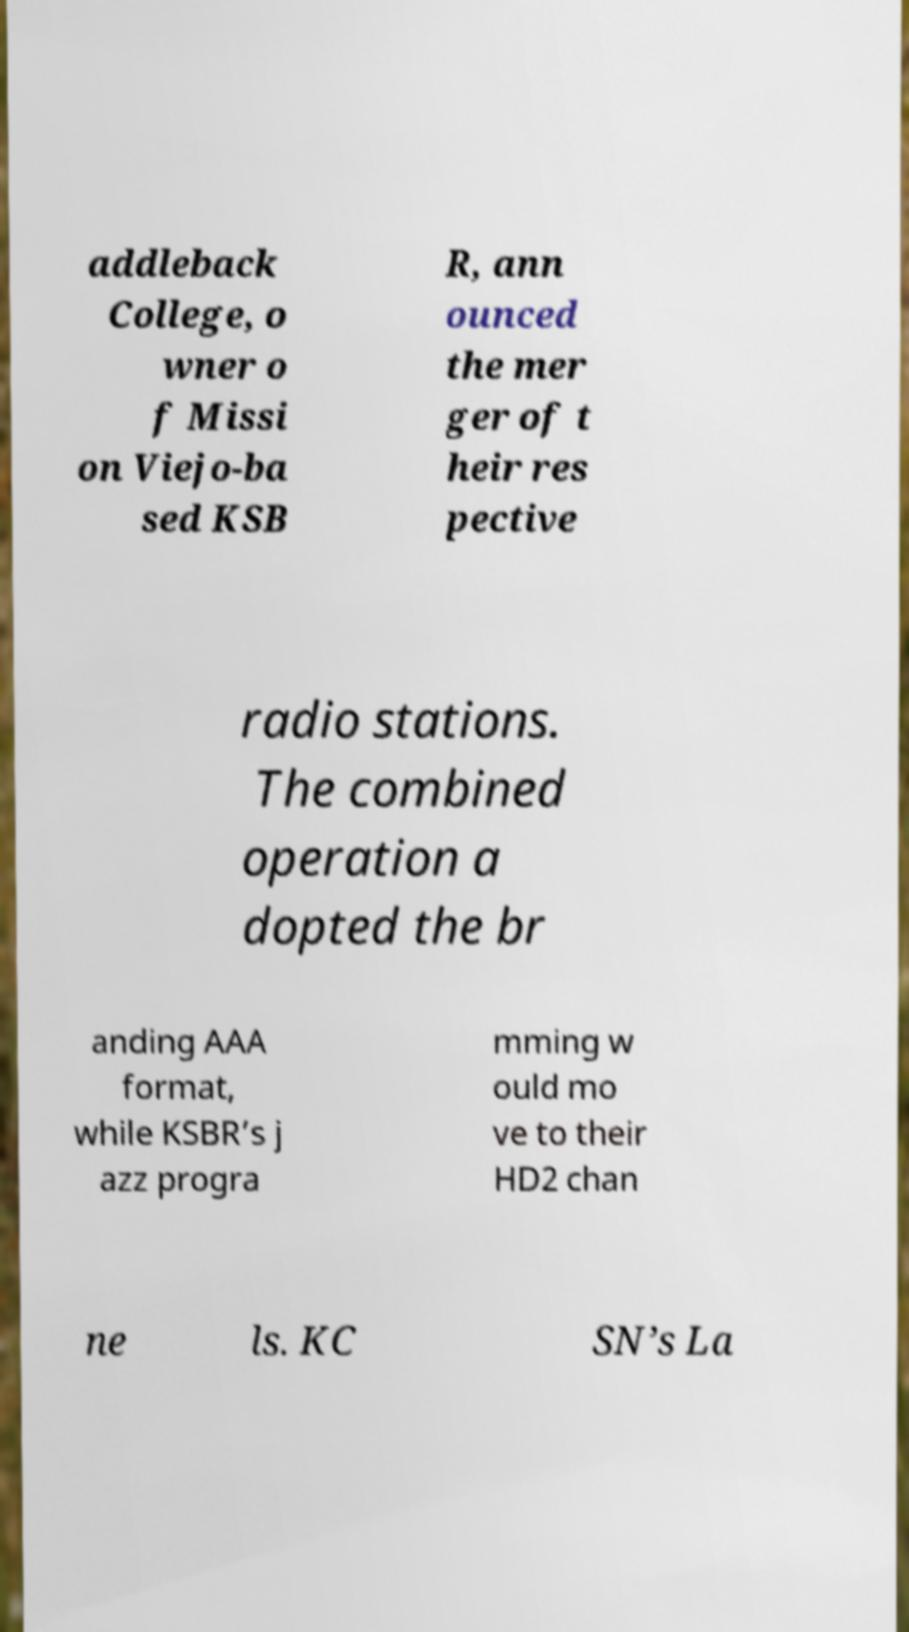Could you extract and type out the text from this image? addleback College, o wner o f Missi on Viejo-ba sed KSB R, ann ounced the mer ger of t heir res pective radio stations. The combined operation a dopted the br anding AAA format, while KSBR’s j azz progra mming w ould mo ve to their HD2 chan ne ls. KC SN’s La 